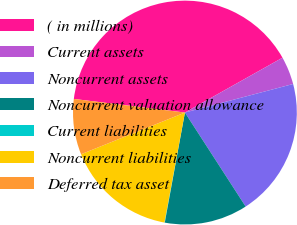Convert chart to OTSL. <chart><loc_0><loc_0><loc_500><loc_500><pie_chart><fcel>( in millions)<fcel>Current assets<fcel>Noncurrent assets<fcel>Noncurrent valuation allowance<fcel>Current liabilities<fcel>Noncurrent liabilities<fcel>Deferred tax asset<nl><fcel>39.91%<fcel>4.04%<fcel>19.98%<fcel>12.01%<fcel>0.05%<fcel>15.99%<fcel>8.02%<nl></chart> 